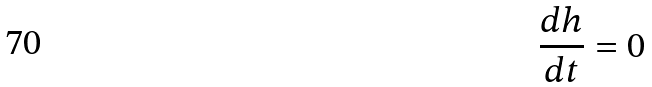Convert formula to latex. <formula><loc_0><loc_0><loc_500><loc_500>\frac { d h } { d t } = 0</formula> 